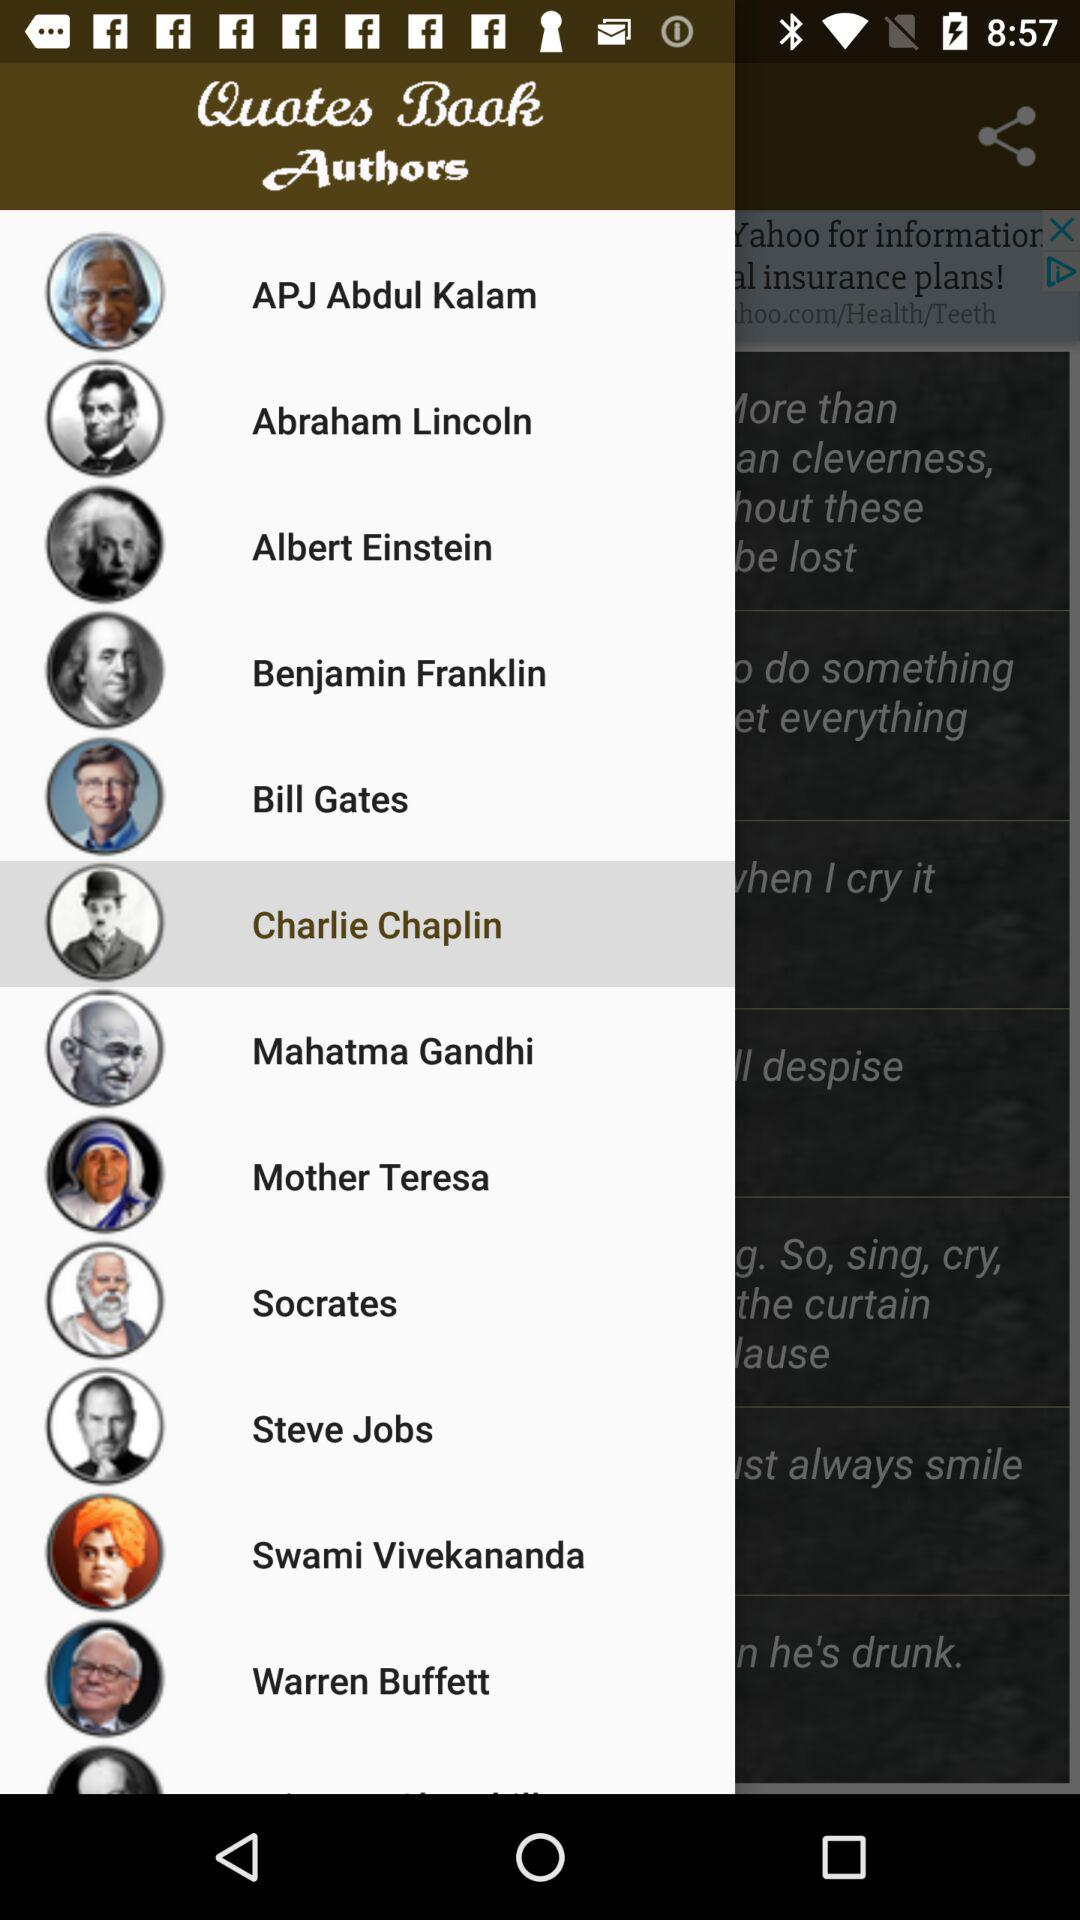Which author was selected? The selected author was Charlie Chaplin. 